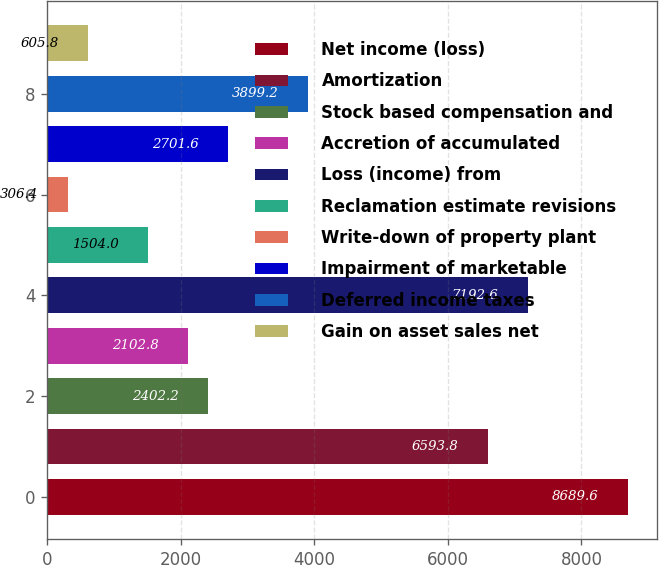Convert chart. <chart><loc_0><loc_0><loc_500><loc_500><bar_chart><fcel>Net income (loss)<fcel>Amortization<fcel>Stock based compensation and<fcel>Accretion of accumulated<fcel>Loss (income) from<fcel>Reclamation estimate revisions<fcel>Write-down of property plant<fcel>Impairment of marketable<fcel>Deferred income taxes<fcel>Gain on asset sales net<nl><fcel>8689.6<fcel>6593.8<fcel>2402.2<fcel>2102.8<fcel>7192.6<fcel>1504<fcel>306.4<fcel>2701.6<fcel>3899.2<fcel>605.8<nl></chart> 